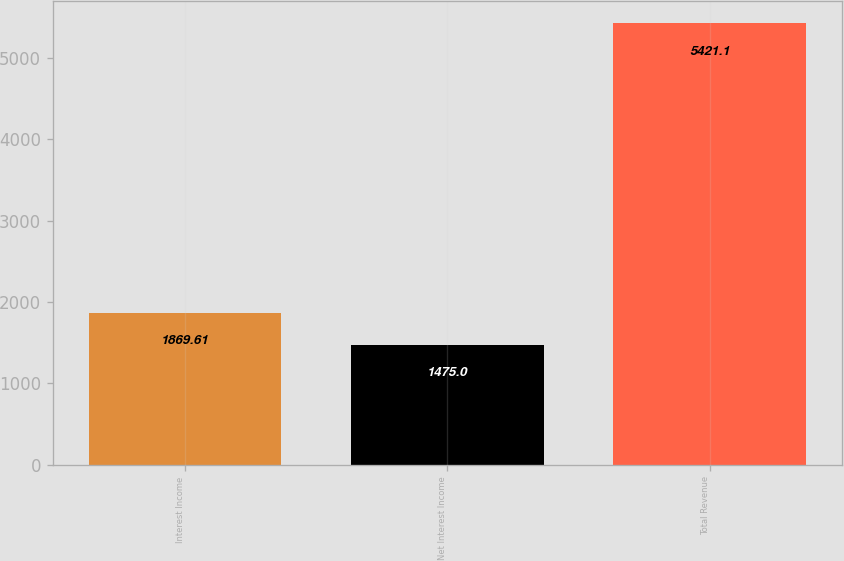<chart> <loc_0><loc_0><loc_500><loc_500><bar_chart><fcel>Interest Income<fcel>Net Interest Income<fcel>Total Revenue<nl><fcel>1869.61<fcel>1475<fcel>5421.1<nl></chart> 